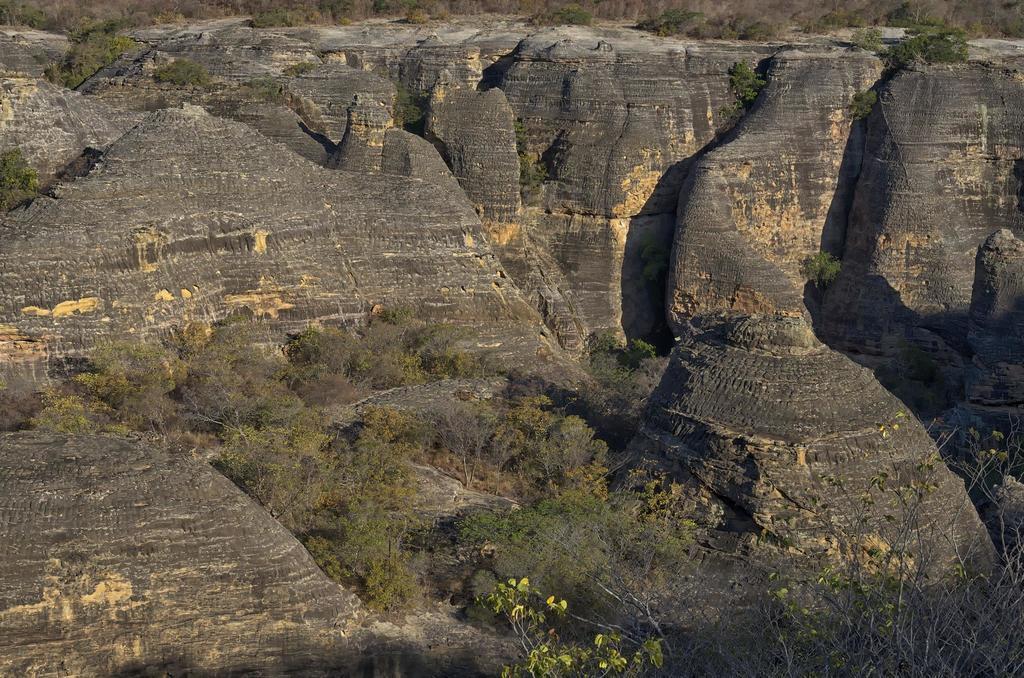Describe this image in one or two sentences. This image is taken outdoors. In this image there are many hills, rocks, trees and plants. 